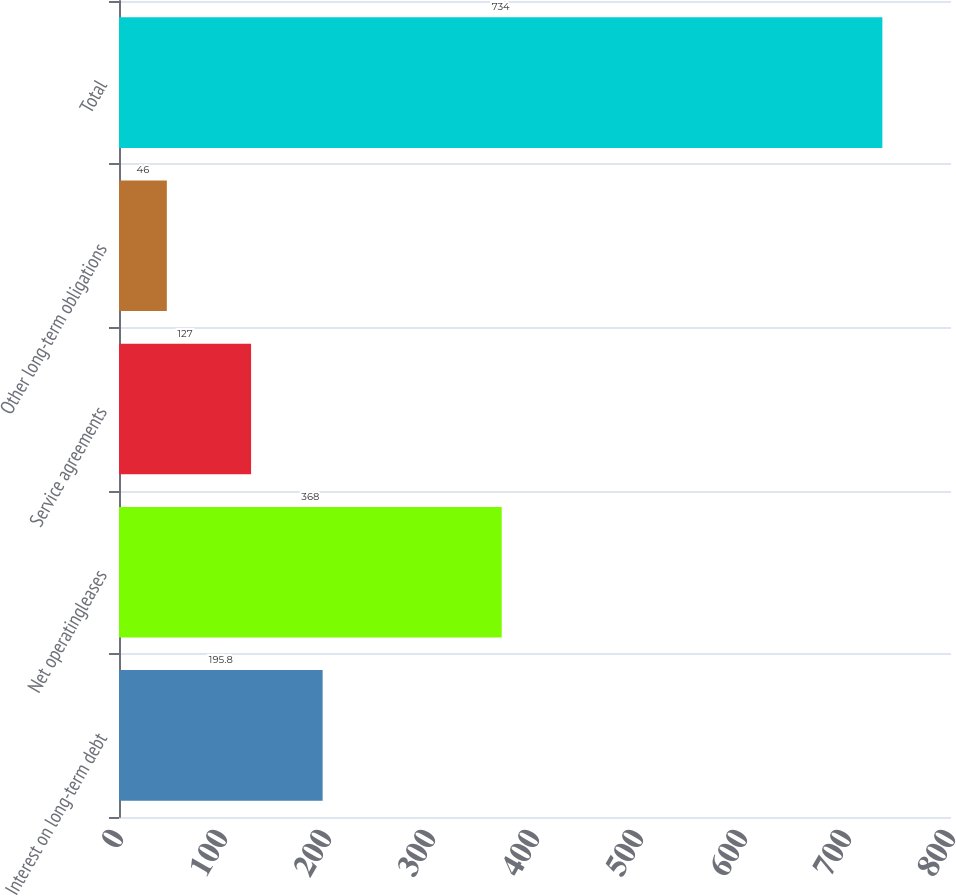Convert chart to OTSL. <chart><loc_0><loc_0><loc_500><loc_500><bar_chart><fcel>Interest on long-term debt<fcel>Net operatingleases<fcel>Service agreements<fcel>Other long-term obligations<fcel>Total<nl><fcel>195.8<fcel>368<fcel>127<fcel>46<fcel>734<nl></chart> 